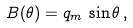<formula> <loc_0><loc_0><loc_500><loc_500>B ( \theta ) = q _ { m } \, \sin \theta \, ,</formula> 